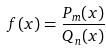Convert formula to latex. <formula><loc_0><loc_0><loc_500><loc_500>f ( x ) = \frac { P _ { m } ( x ) } { Q _ { n } ( x ) }</formula> 